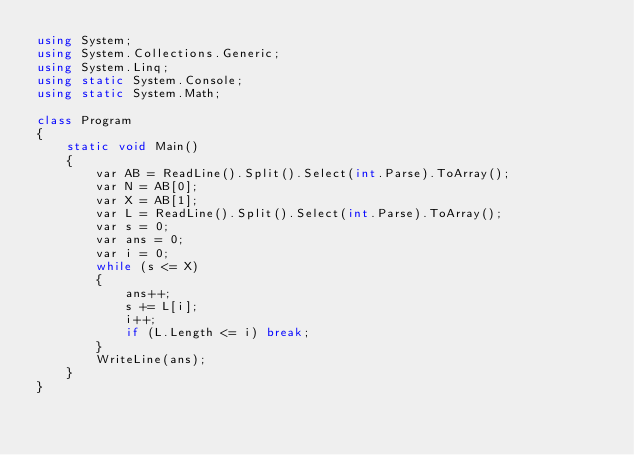Convert code to text. <code><loc_0><loc_0><loc_500><loc_500><_C#_>using System;
using System.Collections.Generic;
using System.Linq;
using static System.Console;
using static System.Math;

class Program
{
    static void Main()
    {
        var AB = ReadLine().Split().Select(int.Parse).ToArray();
        var N = AB[0];
        var X = AB[1];
        var L = ReadLine().Split().Select(int.Parse).ToArray();
        var s = 0;
        var ans = 0;
        var i = 0;
        while (s <= X)
        {
            ans++;
            s += L[i];
            i++;
            if (L.Length <= i) break;
        }
        WriteLine(ans);
    }
}</code> 